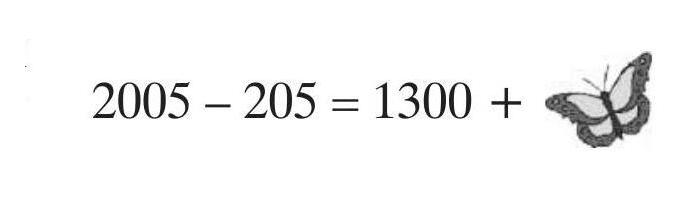What could be the significance of using a butterfly in this mathematical representation? The use of a butterfly, which is often a symbol of transformation and beauty, in the mathematical setup might signify the elegance and simplicity of math. Math often reveals the unexpected beauty in structure and numbers through solutions, much like how a butterfly undergoes transformation and reveals its beauty. This artistic inclusion could be a way to add an element of nature and visual interest to enrich the learning experience. 